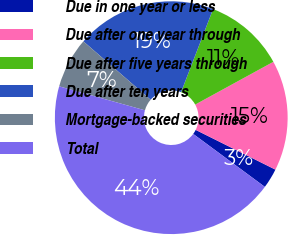Convert chart. <chart><loc_0><loc_0><loc_500><loc_500><pie_chart><fcel>Due in one year or less<fcel>Due after one year through<fcel>Due after five years through<fcel>Due after ten years<fcel>Mortgage-backed securities<fcel>Total<nl><fcel>2.77%<fcel>15.33%<fcel>11.18%<fcel>19.47%<fcel>7.04%<fcel>44.21%<nl></chart> 